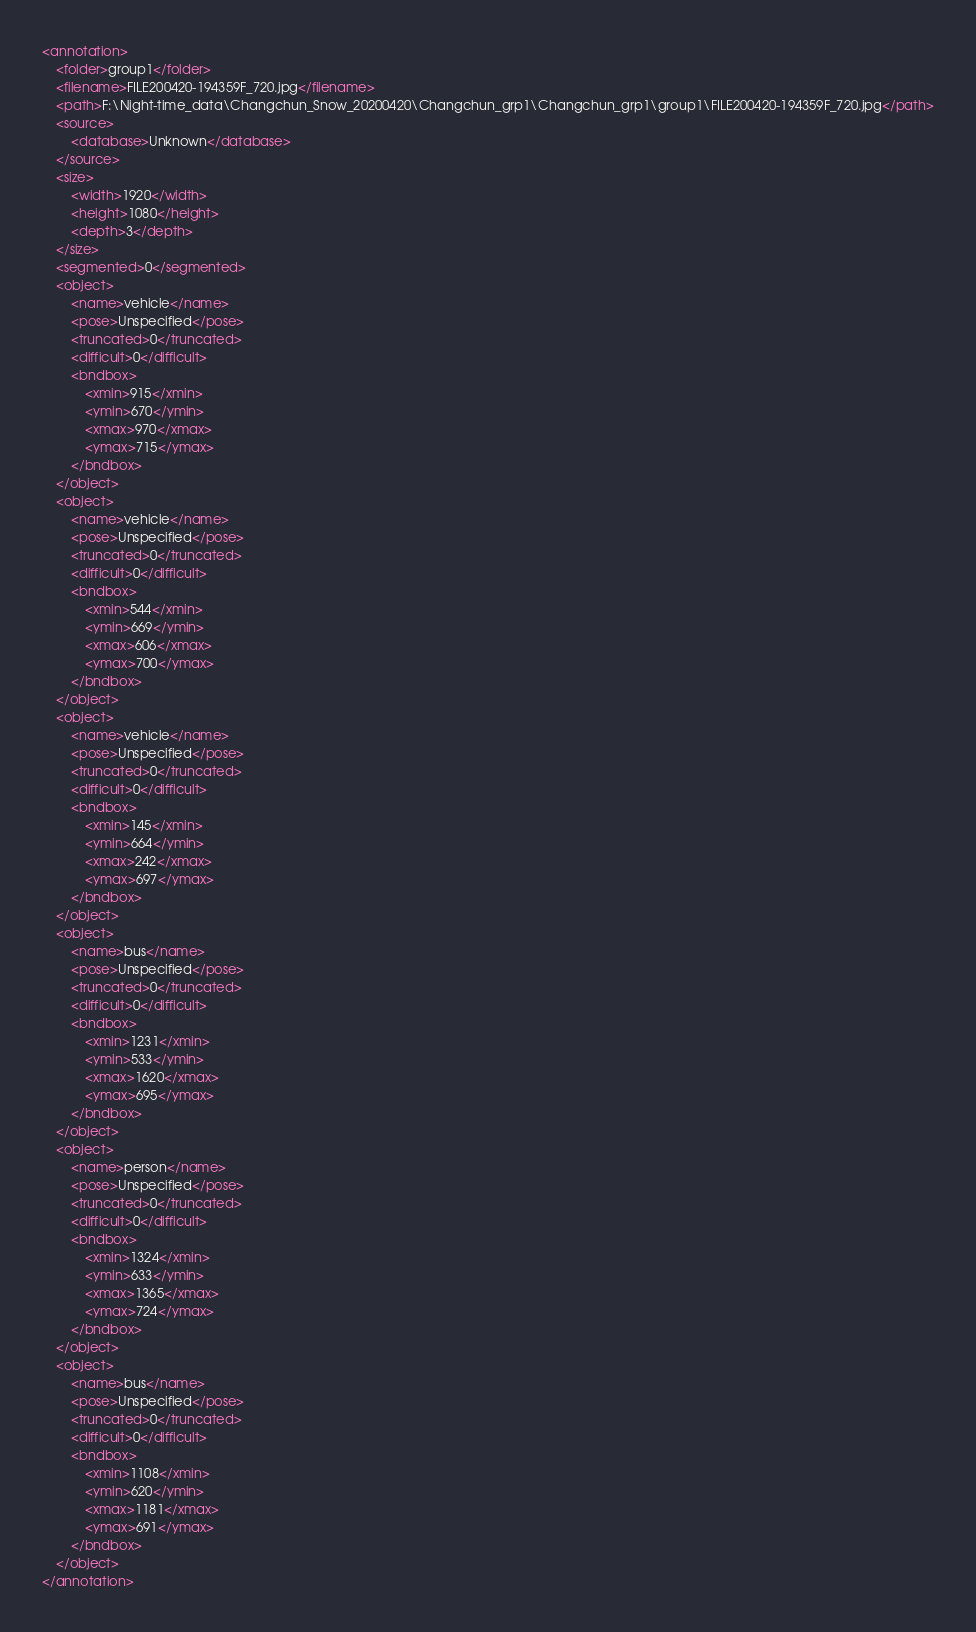Convert code to text. <code><loc_0><loc_0><loc_500><loc_500><_XML_><annotation>
	<folder>group1</folder>
	<filename>FILE200420-194359F_720.jpg</filename>
	<path>F:\Night-time_data\Changchun_Snow_20200420\Changchun_grp1\Changchun_grp1\group1\FILE200420-194359F_720.jpg</path>
	<source>
		<database>Unknown</database>
	</source>
	<size>
		<width>1920</width>
		<height>1080</height>
		<depth>3</depth>
	</size>
	<segmented>0</segmented>
	<object>
		<name>vehicle</name>
		<pose>Unspecified</pose>
		<truncated>0</truncated>
		<difficult>0</difficult>
		<bndbox>
			<xmin>915</xmin>
			<ymin>670</ymin>
			<xmax>970</xmax>
			<ymax>715</ymax>
		</bndbox>
	</object>
	<object>
		<name>vehicle</name>
		<pose>Unspecified</pose>
		<truncated>0</truncated>
		<difficult>0</difficult>
		<bndbox>
			<xmin>544</xmin>
			<ymin>669</ymin>
			<xmax>606</xmax>
			<ymax>700</ymax>
		</bndbox>
	</object>
	<object>
		<name>vehicle</name>
		<pose>Unspecified</pose>
		<truncated>0</truncated>
		<difficult>0</difficult>
		<bndbox>
			<xmin>145</xmin>
			<ymin>664</ymin>
			<xmax>242</xmax>
			<ymax>697</ymax>
		</bndbox>
	</object>
	<object>
		<name>bus</name>
		<pose>Unspecified</pose>
		<truncated>0</truncated>
		<difficult>0</difficult>
		<bndbox>
			<xmin>1231</xmin>
			<ymin>533</ymin>
			<xmax>1620</xmax>
			<ymax>695</ymax>
		</bndbox>
	</object>
	<object>
		<name>person</name>
		<pose>Unspecified</pose>
		<truncated>0</truncated>
		<difficult>0</difficult>
		<bndbox>
			<xmin>1324</xmin>
			<ymin>633</ymin>
			<xmax>1365</xmax>
			<ymax>724</ymax>
		</bndbox>
	</object>
	<object>
		<name>bus</name>
		<pose>Unspecified</pose>
		<truncated>0</truncated>
		<difficult>0</difficult>
		<bndbox>
			<xmin>1108</xmin>
			<ymin>620</ymin>
			<xmax>1181</xmax>
			<ymax>691</ymax>
		</bndbox>
	</object>
</annotation>
</code> 